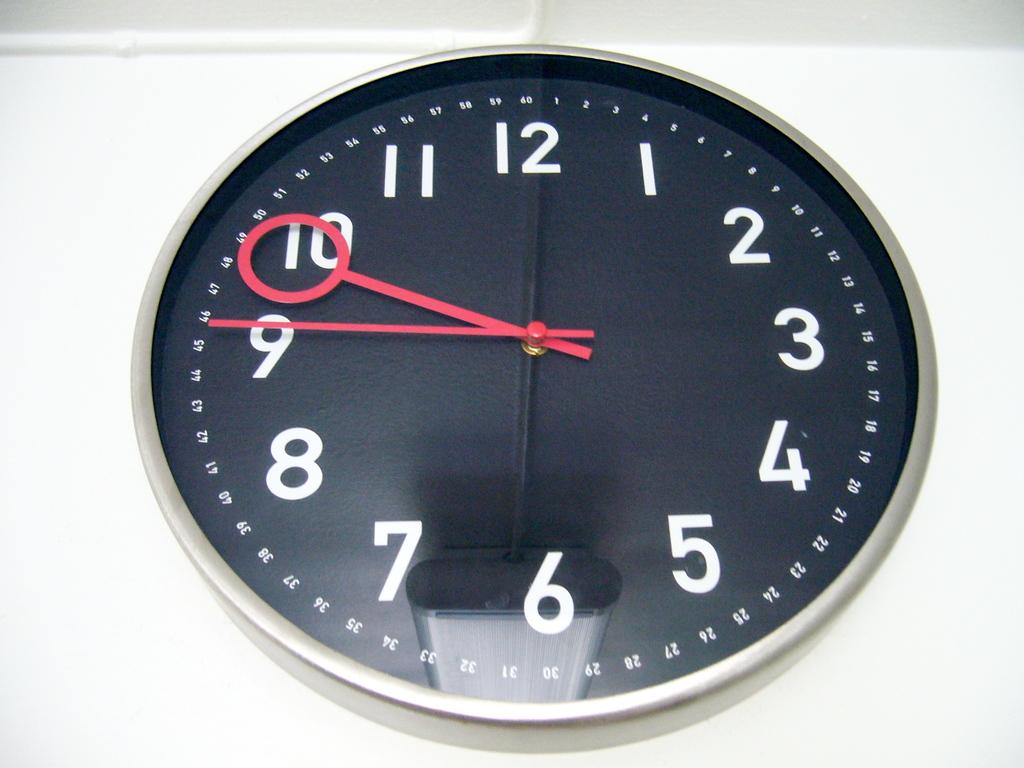What number is the big hand pointing too?
Your response must be concise. 9. 